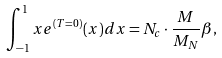<formula> <loc_0><loc_0><loc_500><loc_500>\int _ { - 1 } ^ { 1 } x e ^ { ( T = 0 ) } ( x ) d x = N _ { c } \cdot \frac { M } { M _ { N } } \beta ,</formula> 